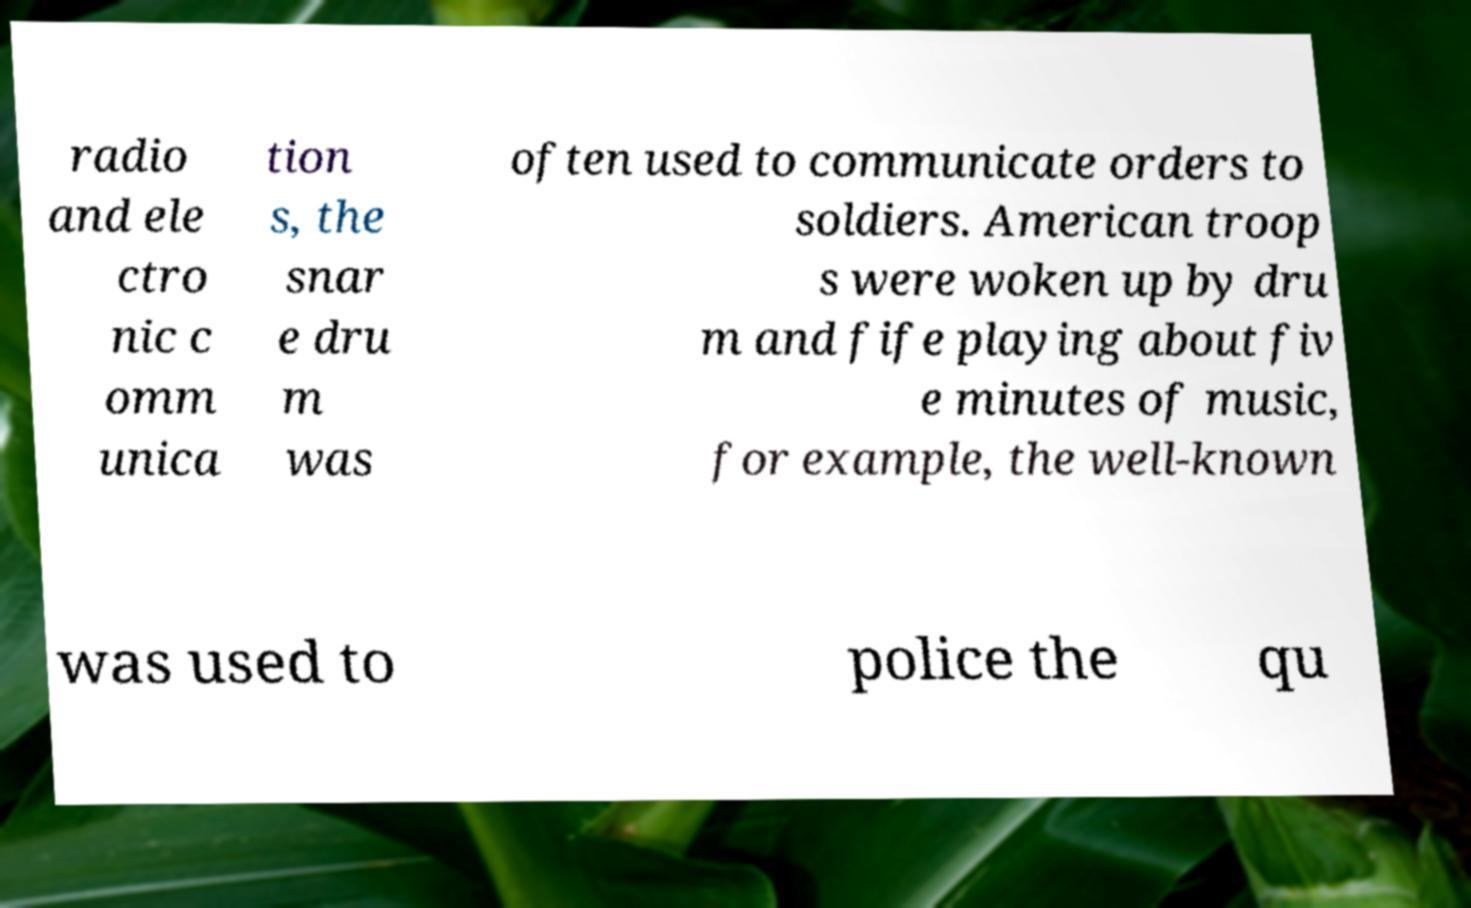What messages or text are displayed in this image? I need them in a readable, typed format. radio and ele ctro nic c omm unica tion s, the snar e dru m was often used to communicate orders to soldiers. American troop s were woken up by dru m and fife playing about fiv e minutes of music, for example, the well-known was used to police the qu 